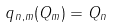<formula> <loc_0><loc_0><loc_500><loc_500>q _ { n , m } ( Q _ { m } ) = Q _ { n }</formula> 